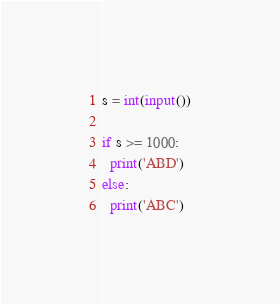<code> <loc_0><loc_0><loc_500><loc_500><_Python_>s = int(input())

if s >= 1000:
  print('ABD')
else:
  print('ABC')</code> 